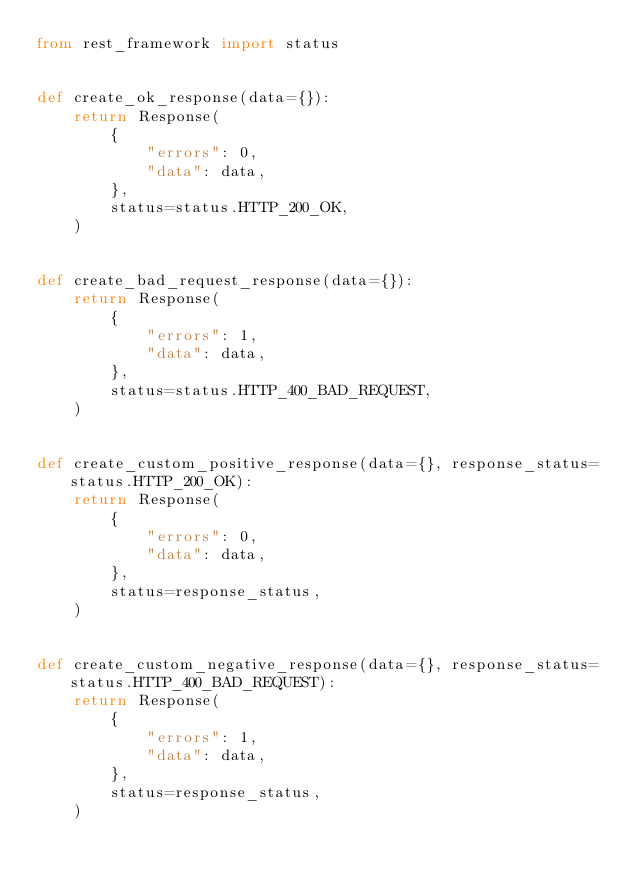Convert code to text. <code><loc_0><loc_0><loc_500><loc_500><_Python_>from rest_framework import status


def create_ok_response(data={}):
    return Response(
        {
            "errors": 0,
            "data": data,
        },
        status=status.HTTP_200_OK,
    )


def create_bad_request_response(data={}):
    return Response(
        {
            "errors": 1,
            "data": data,
        },
        status=status.HTTP_400_BAD_REQUEST,
    )


def create_custom_positive_response(data={}, response_status=status.HTTP_200_OK):
    return Response(
        {
            "errors": 0,
            "data": data,
        },
        status=response_status,
    )


def create_custom_negative_response(data={}, response_status=status.HTTP_400_BAD_REQUEST):
    return Response(
        {
            "errors": 1,
            "data": data,
        },
        status=response_status,
    )
</code> 